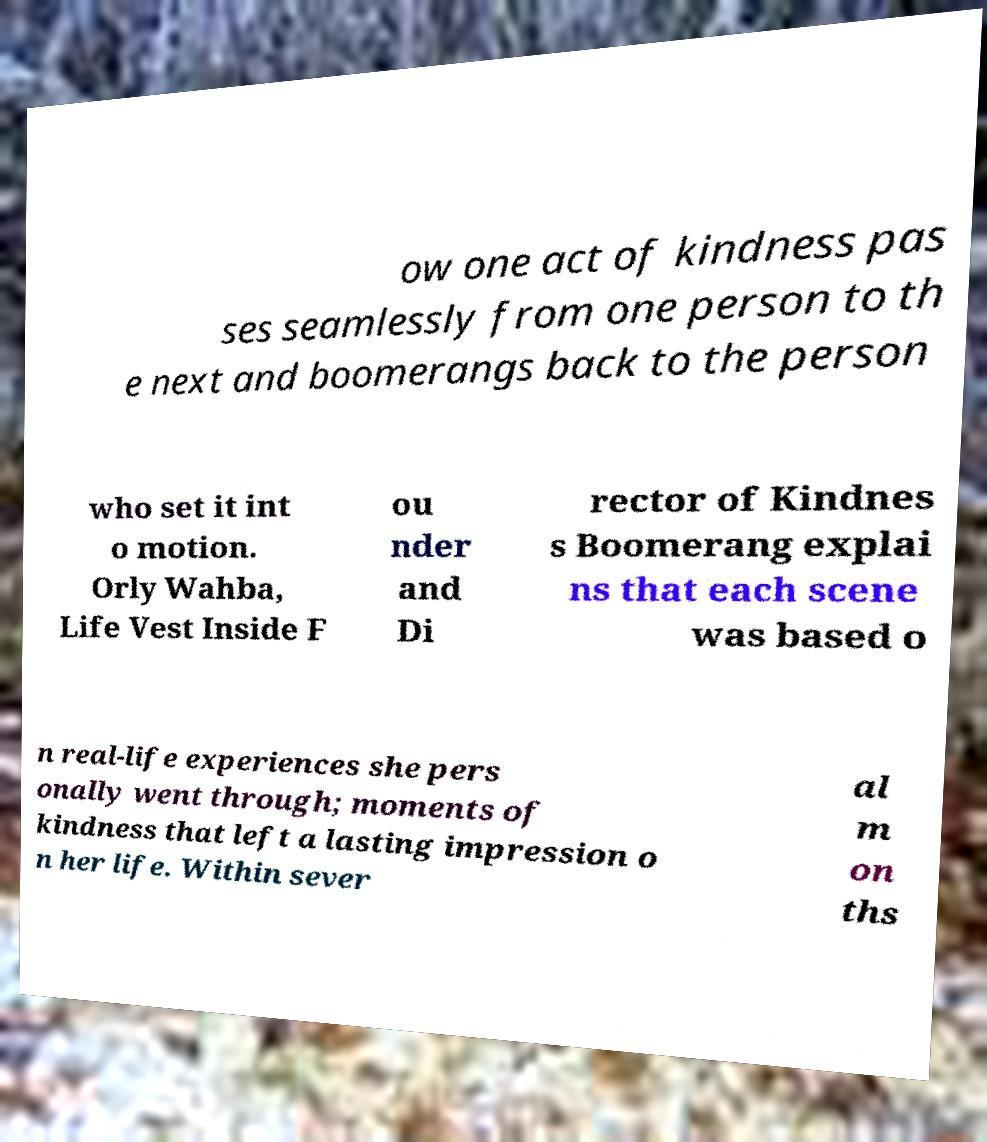I need the written content from this picture converted into text. Can you do that? ow one act of kindness pas ses seamlessly from one person to th e next and boomerangs back to the person who set it int o motion. Orly Wahba, Life Vest Inside F ou nder and Di rector of Kindnes s Boomerang explai ns that each scene was based o n real-life experiences she pers onally went through; moments of kindness that left a lasting impression o n her life. Within sever al m on ths 